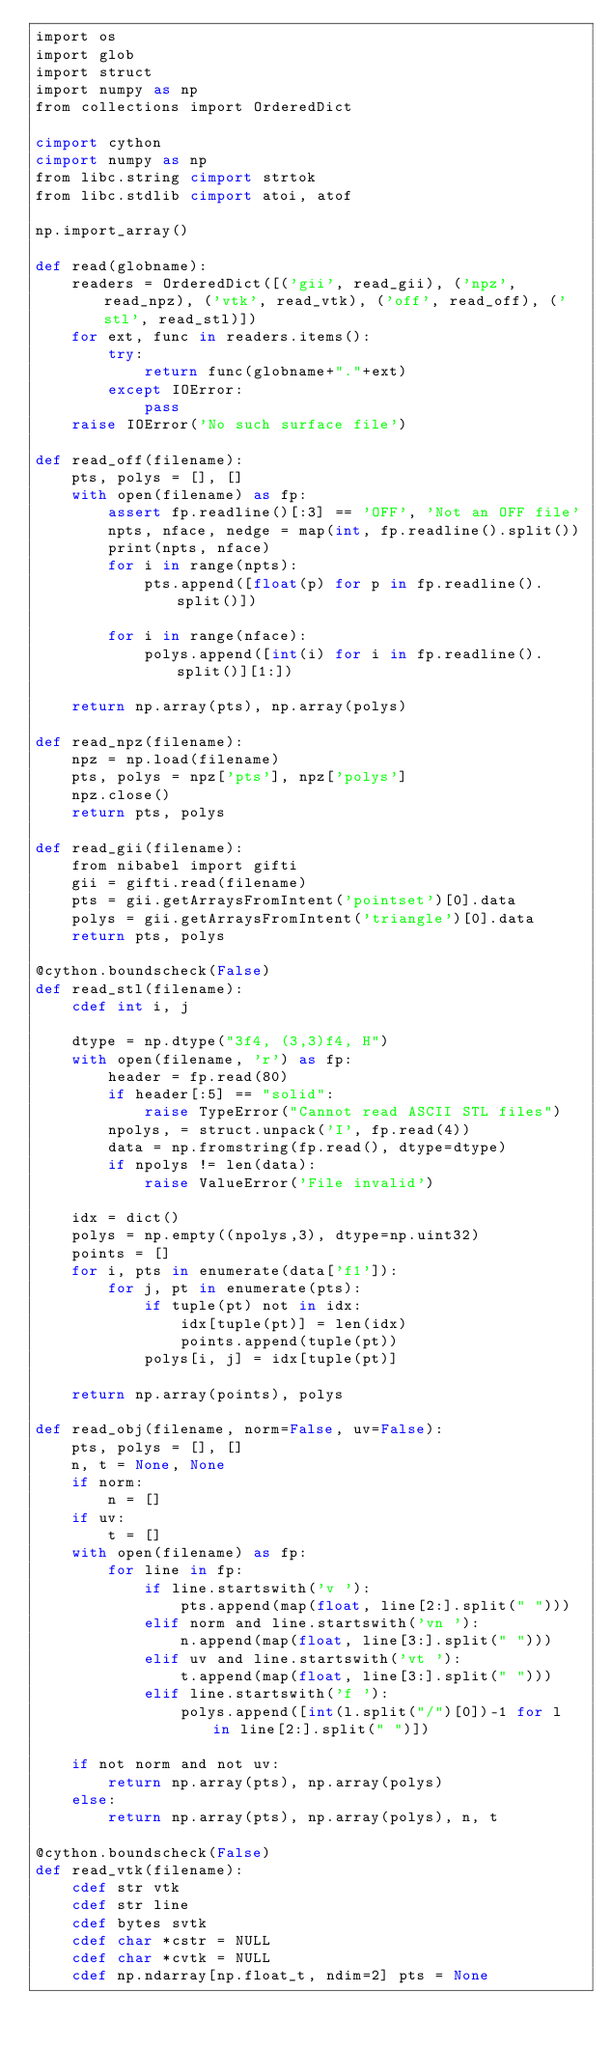Convert code to text. <code><loc_0><loc_0><loc_500><loc_500><_Cython_>import os
import glob
import struct
import numpy as np
from collections import OrderedDict

cimport cython
cimport numpy as np
from libc.string cimport strtok
from libc.stdlib cimport atoi, atof

np.import_array()

def read(globname):
    readers = OrderedDict([('gii', read_gii), ('npz', read_npz), ('vtk', read_vtk), ('off', read_off), ('stl', read_stl)])
    for ext, func in readers.items():
        try:
            return func(globname+"."+ext)
        except IOError:
            pass
    raise IOError('No such surface file')

def read_off(filename):
    pts, polys = [], []
    with open(filename) as fp:
        assert fp.readline()[:3] == 'OFF', 'Not an OFF file'
        npts, nface, nedge = map(int, fp.readline().split())
        print(npts, nface)
        for i in range(npts):
            pts.append([float(p) for p in fp.readline().split()])

        for i in range(nface):
            polys.append([int(i) for i in fp.readline().split()][1:])

    return np.array(pts), np.array(polys)

def read_npz(filename):
    npz = np.load(filename)
    pts, polys = npz['pts'], npz['polys']
    npz.close()
    return pts, polys

def read_gii(filename):
    from nibabel import gifti
    gii = gifti.read(filename)
    pts = gii.getArraysFromIntent('pointset')[0].data
    polys = gii.getArraysFromIntent('triangle')[0].data
    return pts, polys

@cython.boundscheck(False)
def read_stl(filename):
    cdef int i, j

    dtype = np.dtype("3f4, (3,3)f4, H")
    with open(filename, 'r') as fp:
        header = fp.read(80)
        if header[:5] == "solid":
            raise TypeError("Cannot read ASCII STL files")
        npolys, = struct.unpack('I', fp.read(4))
        data = np.fromstring(fp.read(), dtype=dtype)
        if npolys != len(data):
            raise ValueError('File invalid')

    idx = dict()
    polys = np.empty((npolys,3), dtype=np.uint32)
    points = []
    for i, pts in enumerate(data['f1']):
        for j, pt in enumerate(pts):
            if tuple(pt) not in idx:
                idx[tuple(pt)] = len(idx)
                points.append(tuple(pt))
            polys[i, j] = idx[tuple(pt)]

    return np.array(points), polys

def read_obj(filename, norm=False, uv=False):
    pts, polys = [], []
    n, t = None, None
    if norm:
        n = []
    if uv:
        t = []
    with open(filename) as fp:
        for line in fp:
            if line.startswith('v '):
                pts.append(map(float, line[2:].split(" ")))
            elif norm and line.startswith('vn '):
                n.append(map(float, line[3:].split(" ")))
            elif uv and line.startswith('vt '):
                t.append(map(float, line[3:].split(" ")))
            elif line.startswith('f '):
                polys.append([int(l.split("/")[0])-1 for l in line[2:].split(" ")])

    if not norm and not uv:
        return np.array(pts), np.array(polys)
    else:
        return np.array(pts), np.array(polys), n, t

@cython.boundscheck(False)
def read_vtk(filename):
    cdef str vtk
    cdef str line
    cdef bytes svtk
    cdef char *cstr = NULL
    cdef char *cvtk = NULL
    cdef np.ndarray[np.float_t, ndim=2] pts = None</code> 